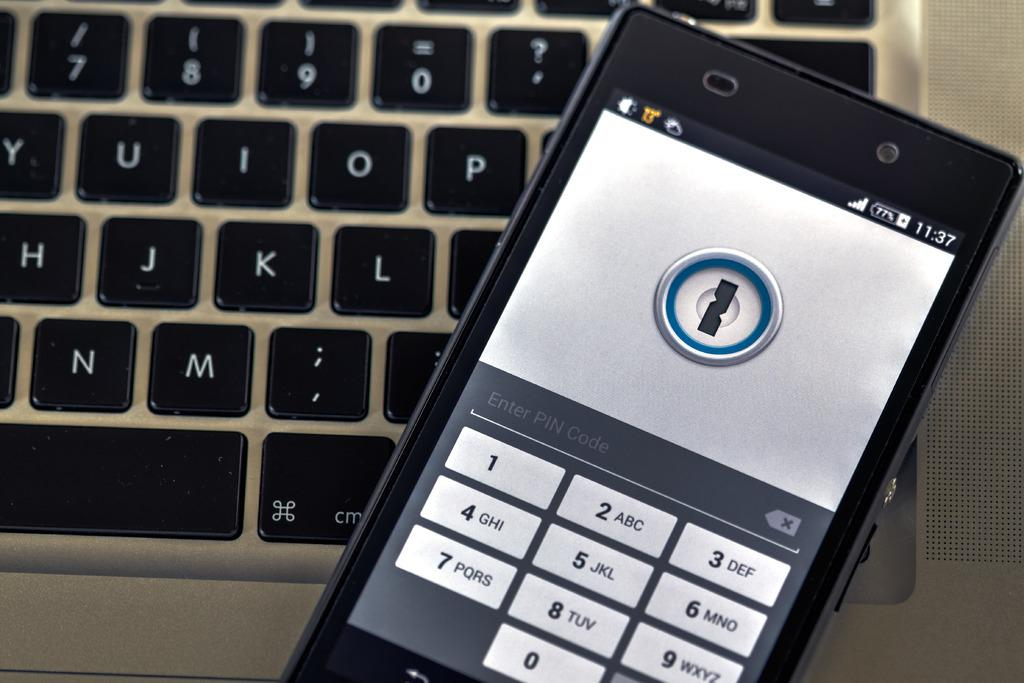Provide a one-sentence caption for the provided image. a phone with the time of 11:37 shown on it. 